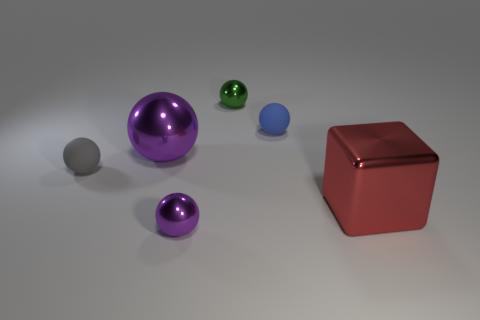What materials are the objects in this image made of? The objects seem to have different materials. The large purple and the small green spheres have a reflective, possibly metallic surface. The cube is also shiny and might be metallic, whereas the small purple sphere and the larger grey sphere have a matte finish suggesting a non-metallic material, possibly plastic. 